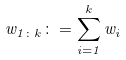<formula> <loc_0><loc_0><loc_500><loc_500>w _ { 1 \colon k } \colon = \sum _ { i = 1 } ^ { k } w _ { i }</formula> 